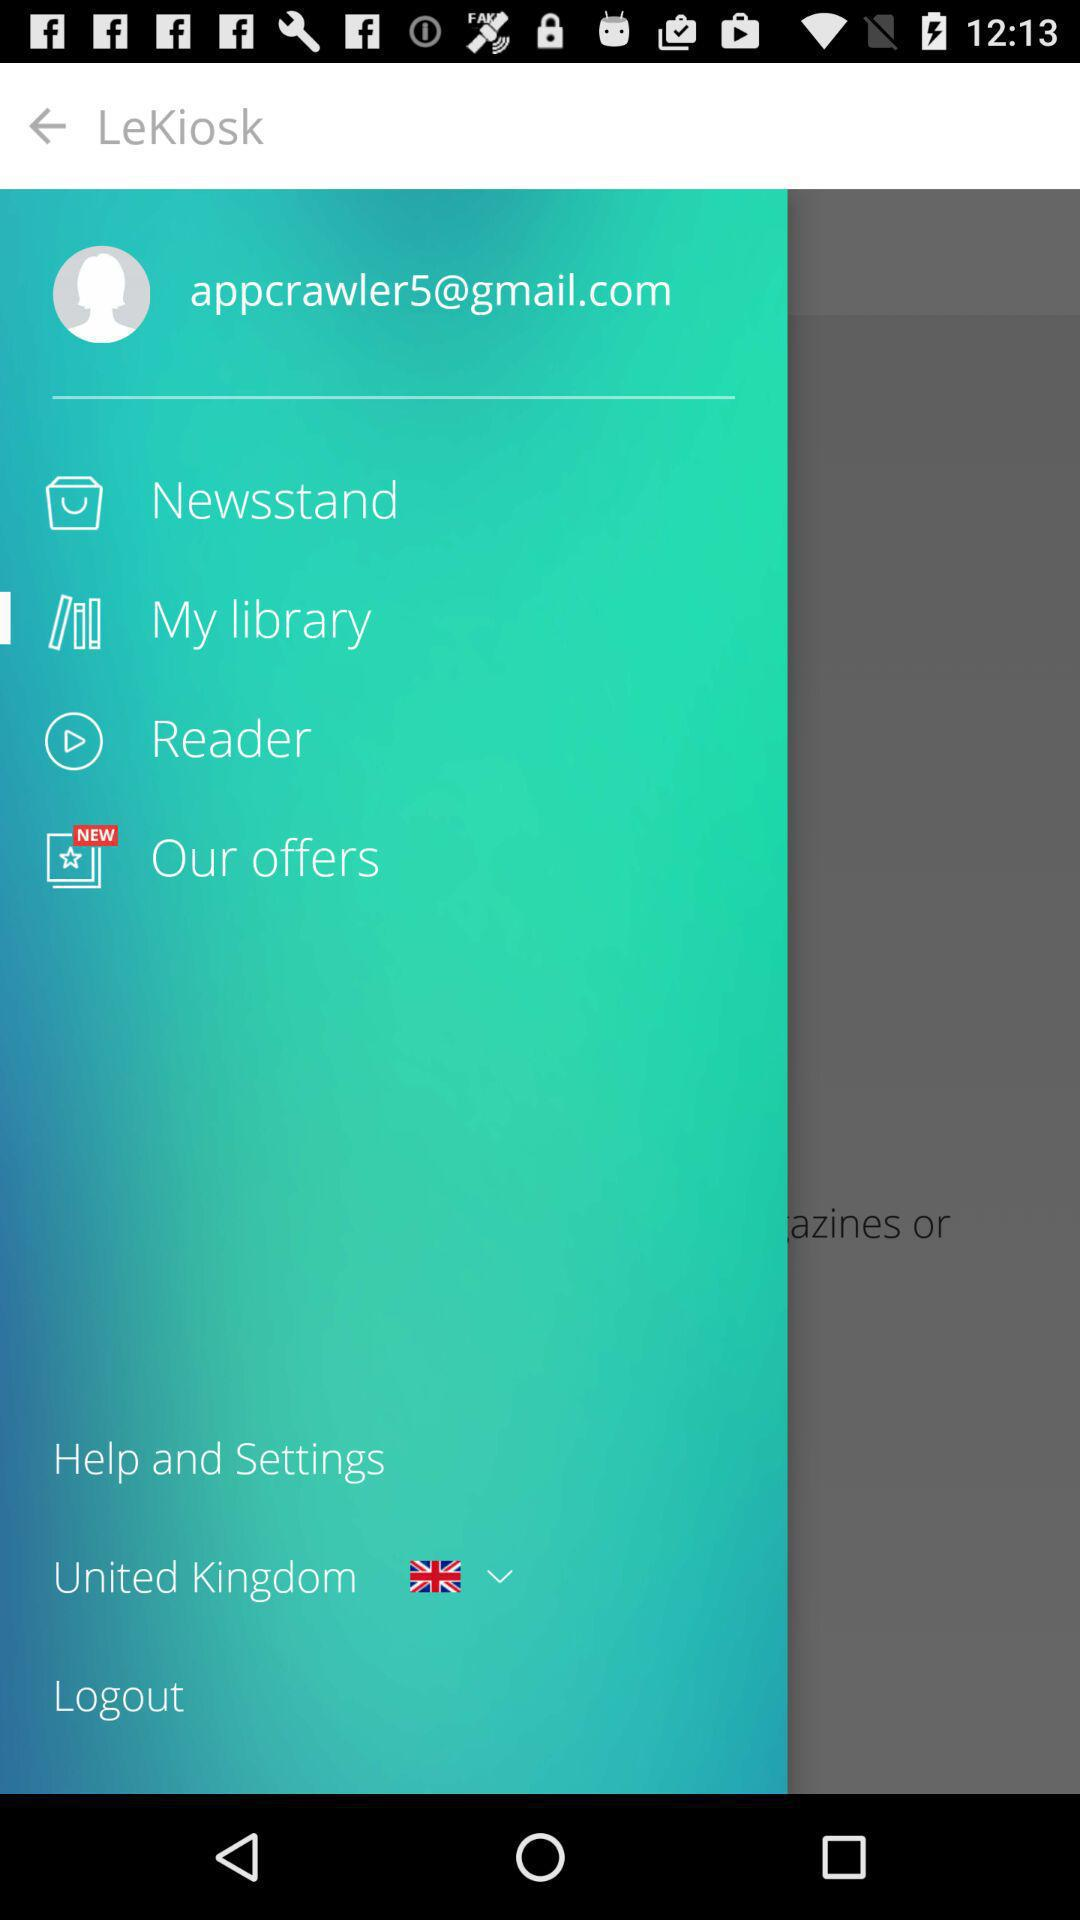Which country is selected? The selected country is the United Kingdom. 